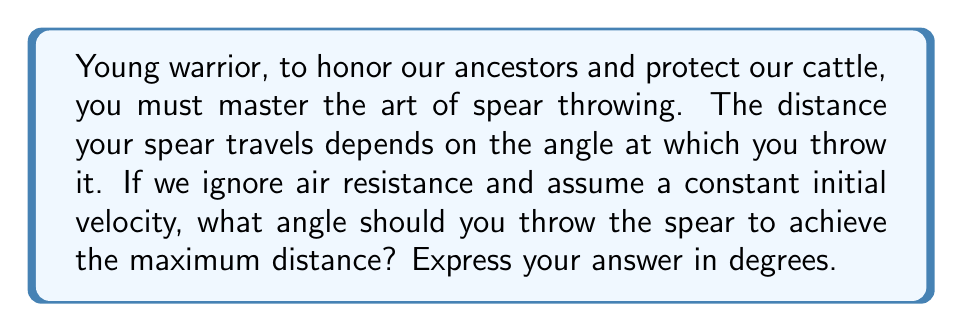Could you help me with this problem? Let's approach this step-by-step:

1) In physics, the motion of a projectile (like a spear) follows a parabolic path. The range (horizontal distance) of the projectile is given by the formula:

   $$R = \frac{v^2 \sin(2\theta)}{g}$$

   Where:
   $R$ is the range
   $v$ is the initial velocity
   $\theta$ is the angle of launch
   $g$ is the acceleration due to gravity

2) To find the maximum range, we need to maximize $\sin(2\theta)$.

3) The sine function reaches its maximum value of 1 when its argument is 90°.

4) So, we want:

   $$2\theta = 90°$$

5) Solving for $\theta$:

   $$\theta = 45°$$

6) This result is independent of the initial velocity and the acceleration due to gravity, making it a universal principle for projectile motion in a uniform gravitational field without air resistance.

[asy]
import graph;
size(200,200);
real f(real x) {return -x^2+x;}
draw(graph(f,0,1));
draw((0,0)--(1,0),arrow=Arrow(TeXHead));
draw((0,0)--(0,0.3),arrow=Arrow(TeXHead));
label("Ground",(0.5,-0.05),S);
label("Height",(-.05,0.15),W);
draw((0,0)--(0.5,0.25),arrow=Arrow(TeXHead));
label("45°",(0.1,0.05),NE);
label("Spear path",(0.7,0.2),N);
[/asy]
Answer: 45° 